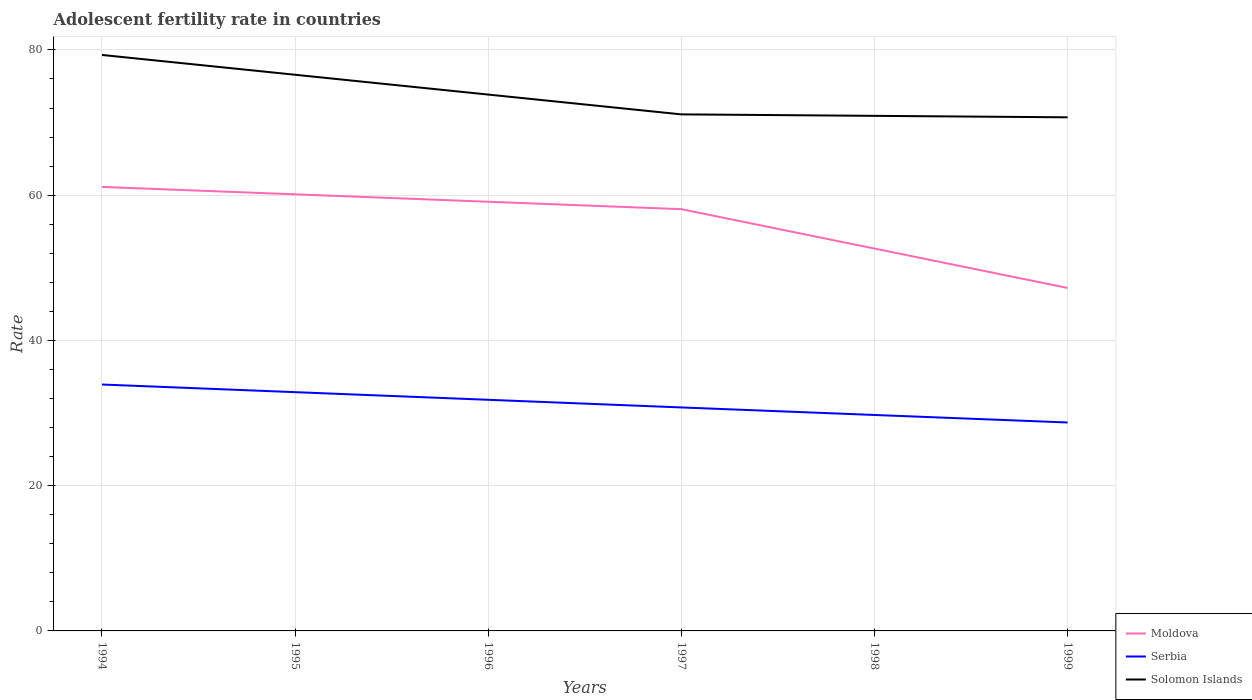Is the number of lines equal to the number of legend labels?
Your response must be concise. Yes. Across all years, what is the maximum adolescent fertility rate in Moldova?
Keep it short and to the point. 47.23. In which year was the adolescent fertility rate in Moldova maximum?
Offer a very short reply. 1999. What is the total adolescent fertility rate in Solomon Islands in the graph?
Offer a terse response. 0.4. What is the difference between the highest and the second highest adolescent fertility rate in Moldova?
Offer a terse response. 13.91. What is the difference between the highest and the lowest adolescent fertility rate in Serbia?
Your response must be concise. 3. Is the adolescent fertility rate in Moldova strictly greater than the adolescent fertility rate in Serbia over the years?
Offer a terse response. No. Are the values on the major ticks of Y-axis written in scientific E-notation?
Give a very brief answer. No. Where does the legend appear in the graph?
Your answer should be compact. Bottom right. How many legend labels are there?
Provide a succinct answer. 3. What is the title of the graph?
Offer a very short reply. Adolescent fertility rate in countries. Does "Vietnam" appear as one of the legend labels in the graph?
Provide a short and direct response. No. What is the label or title of the X-axis?
Provide a succinct answer. Years. What is the label or title of the Y-axis?
Provide a succinct answer. Rate. What is the Rate of Moldova in 1994?
Your answer should be very brief. 61.14. What is the Rate in Serbia in 1994?
Offer a terse response. 33.93. What is the Rate of Solomon Islands in 1994?
Provide a succinct answer. 79.31. What is the Rate in Moldova in 1995?
Your response must be concise. 60.11. What is the Rate of Serbia in 1995?
Offer a terse response. 32.88. What is the Rate in Solomon Islands in 1995?
Your answer should be very brief. 76.58. What is the Rate in Moldova in 1996?
Provide a short and direct response. 59.09. What is the Rate of Serbia in 1996?
Provide a short and direct response. 31.82. What is the Rate in Solomon Islands in 1996?
Keep it short and to the point. 73.85. What is the Rate of Moldova in 1997?
Offer a very short reply. 58.07. What is the Rate of Serbia in 1997?
Ensure brevity in your answer.  30.77. What is the Rate of Solomon Islands in 1997?
Ensure brevity in your answer.  71.12. What is the Rate in Moldova in 1998?
Give a very brief answer. 52.65. What is the Rate of Serbia in 1998?
Provide a succinct answer. 29.74. What is the Rate of Solomon Islands in 1998?
Your answer should be compact. 70.92. What is the Rate in Moldova in 1999?
Provide a succinct answer. 47.23. What is the Rate of Serbia in 1999?
Ensure brevity in your answer.  28.7. What is the Rate in Solomon Islands in 1999?
Offer a terse response. 70.72. Across all years, what is the maximum Rate in Moldova?
Give a very brief answer. 61.14. Across all years, what is the maximum Rate of Serbia?
Your answer should be compact. 33.93. Across all years, what is the maximum Rate in Solomon Islands?
Keep it short and to the point. 79.31. Across all years, what is the minimum Rate in Moldova?
Provide a succinct answer. 47.23. Across all years, what is the minimum Rate in Serbia?
Provide a short and direct response. 28.7. Across all years, what is the minimum Rate in Solomon Islands?
Your response must be concise. 70.72. What is the total Rate in Moldova in the graph?
Make the answer very short. 338.29. What is the total Rate in Serbia in the graph?
Your answer should be very brief. 187.83. What is the total Rate of Solomon Islands in the graph?
Your answer should be compact. 442.5. What is the difference between the Rate of Moldova in 1994 and that in 1995?
Your answer should be compact. 1.02. What is the difference between the Rate of Serbia in 1994 and that in 1995?
Your answer should be very brief. 1.05. What is the difference between the Rate of Solomon Islands in 1994 and that in 1995?
Your response must be concise. 2.73. What is the difference between the Rate of Moldova in 1994 and that in 1996?
Your answer should be very brief. 2.04. What is the difference between the Rate in Serbia in 1994 and that in 1996?
Give a very brief answer. 2.1. What is the difference between the Rate in Solomon Islands in 1994 and that in 1996?
Provide a short and direct response. 5.46. What is the difference between the Rate in Moldova in 1994 and that in 1997?
Your answer should be very brief. 3.06. What is the difference between the Rate in Serbia in 1994 and that in 1997?
Your answer should be compact. 3.16. What is the difference between the Rate in Solomon Islands in 1994 and that in 1997?
Your answer should be compact. 8.18. What is the difference between the Rate of Moldova in 1994 and that in 1998?
Provide a short and direct response. 8.49. What is the difference between the Rate in Serbia in 1994 and that in 1998?
Offer a very short reply. 4.19. What is the difference between the Rate of Solomon Islands in 1994 and that in 1998?
Give a very brief answer. 8.38. What is the difference between the Rate in Moldova in 1994 and that in 1999?
Keep it short and to the point. 13.91. What is the difference between the Rate of Serbia in 1994 and that in 1999?
Your answer should be very brief. 5.23. What is the difference between the Rate of Solomon Islands in 1994 and that in 1999?
Keep it short and to the point. 8.59. What is the difference between the Rate of Moldova in 1995 and that in 1996?
Ensure brevity in your answer.  1.02. What is the difference between the Rate in Serbia in 1995 and that in 1996?
Provide a succinct answer. 1.05. What is the difference between the Rate in Solomon Islands in 1995 and that in 1996?
Provide a succinct answer. 2.73. What is the difference between the Rate in Moldova in 1995 and that in 1997?
Your response must be concise. 2.04. What is the difference between the Rate in Serbia in 1995 and that in 1997?
Give a very brief answer. 2.1. What is the difference between the Rate of Solomon Islands in 1995 and that in 1997?
Keep it short and to the point. 5.46. What is the difference between the Rate in Moldova in 1995 and that in 1998?
Offer a terse response. 7.47. What is the difference between the Rate in Serbia in 1995 and that in 1998?
Make the answer very short. 3.14. What is the difference between the Rate in Solomon Islands in 1995 and that in 1998?
Give a very brief answer. 5.66. What is the difference between the Rate in Moldova in 1995 and that in 1999?
Provide a short and direct response. 12.89. What is the difference between the Rate of Serbia in 1995 and that in 1999?
Make the answer very short. 4.18. What is the difference between the Rate of Solomon Islands in 1995 and that in 1999?
Your response must be concise. 5.86. What is the difference between the Rate of Moldova in 1996 and that in 1997?
Ensure brevity in your answer.  1.02. What is the difference between the Rate in Serbia in 1996 and that in 1997?
Your response must be concise. 1.05. What is the difference between the Rate in Solomon Islands in 1996 and that in 1997?
Ensure brevity in your answer.  2.73. What is the difference between the Rate of Moldova in 1996 and that in 1998?
Ensure brevity in your answer.  6.44. What is the difference between the Rate in Serbia in 1996 and that in 1998?
Offer a terse response. 2.09. What is the difference between the Rate of Solomon Islands in 1996 and that in 1998?
Give a very brief answer. 2.93. What is the difference between the Rate of Moldova in 1996 and that in 1999?
Your answer should be compact. 11.87. What is the difference between the Rate in Serbia in 1996 and that in 1999?
Keep it short and to the point. 3.12. What is the difference between the Rate of Solomon Islands in 1996 and that in 1999?
Offer a terse response. 3.13. What is the difference between the Rate in Moldova in 1997 and that in 1998?
Your answer should be very brief. 5.42. What is the difference between the Rate in Serbia in 1997 and that in 1998?
Keep it short and to the point. 1.04. What is the difference between the Rate in Solomon Islands in 1997 and that in 1998?
Provide a succinct answer. 0.2. What is the difference between the Rate in Moldova in 1997 and that in 1999?
Provide a short and direct response. 10.85. What is the difference between the Rate of Serbia in 1997 and that in 1999?
Ensure brevity in your answer.  2.07. What is the difference between the Rate in Solomon Islands in 1997 and that in 1999?
Give a very brief answer. 0.4. What is the difference between the Rate in Moldova in 1998 and that in 1999?
Provide a succinct answer. 5.42. What is the difference between the Rate in Serbia in 1998 and that in 1999?
Your answer should be compact. 1.04. What is the difference between the Rate of Solomon Islands in 1998 and that in 1999?
Your answer should be very brief. 0.2. What is the difference between the Rate in Moldova in 1994 and the Rate in Serbia in 1995?
Offer a very short reply. 28.26. What is the difference between the Rate of Moldova in 1994 and the Rate of Solomon Islands in 1995?
Make the answer very short. -15.44. What is the difference between the Rate of Serbia in 1994 and the Rate of Solomon Islands in 1995?
Your answer should be very brief. -42.65. What is the difference between the Rate of Moldova in 1994 and the Rate of Serbia in 1996?
Make the answer very short. 29.31. What is the difference between the Rate of Moldova in 1994 and the Rate of Solomon Islands in 1996?
Offer a terse response. -12.71. What is the difference between the Rate of Serbia in 1994 and the Rate of Solomon Islands in 1996?
Your response must be concise. -39.92. What is the difference between the Rate of Moldova in 1994 and the Rate of Serbia in 1997?
Offer a terse response. 30.36. What is the difference between the Rate in Moldova in 1994 and the Rate in Solomon Islands in 1997?
Your answer should be very brief. -9.99. What is the difference between the Rate in Serbia in 1994 and the Rate in Solomon Islands in 1997?
Your answer should be compact. -37.19. What is the difference between the Rate of Moldova in 1994 and the Rate of Serbia in 1998?
Keep it short and to the point. 31.4. What is the difference between the Rate of Moldova in 1994 and the Rate of Solomon Islands in 1998?
Offer a terse response. -9.79. What is the difference between the Rate of Serbia in 1994 and the Rate of Solomon Islands in 1998?
Ensure brevity in your answer.  -36.99. What is the difference between the Rate in Moldova in 1994 and the Rate in Serbia in 1999?
Give a very brief answer. 32.44. What is the difference between the Rate of Moldova in 1994 and the Rate of Solomon Islands in 1999?
Offer a terse response. -9.58. What is the difference between the Rate in Serbia in 1994 and the Rate in Solomon Islands in 1999?
Ensure brevity in your answer.  -36.79. What is the difference between the Rate in Moldova in 1995 and the Rate in Serbia in 1996?
Provide a succinct answer. 28.29. What is the difference between the Rate of Moldova in 1995 and the Rate of Solomon Islands in 1996?
Your answer should be compact. -13.74. What is the difference between the Rate of Serbia in 1995 and the Rate of Solomon Islands in 1996?
Offer a terse response. -40.97. What is the difference between the Rate of Moldova in 1995 and the Rate of Serbia in 1997?
Make the answer very short. 29.34. What is the difference between the Rate of Moldova in 1995 and the Rate of Solomon Islands in 1997?
Make the answer very short. -11.01. What is the difference between the Rate in Serbia in 1995 and the Rate in Solomon Islands in 1997?
Offer a terse response. -38.25. What is the difference between the Rate of Moldova in 1995 and the Rate of Serbia in 1998?
Offer a terse response. 30.38. What is the difference between the Rate of Moldova in 1995 and the Rate of Solomon Islands in 1998?
Ensure brevity in your answer.  -10.81. What is the difference between the Rate in Serbia in 1995 and the Rate in Solomon Islands in 1998?
Keep it short and to the point. -38.05. What is the difference between the Rate of Moldova in 1995 and the Rate of Serbia in 1999?
Provide a succinct answer. 31.41. What is the difference between the Rate of Moldova in 1995 and the Rate of Solomon Islands in 1999?
Your response must be concise. -10.6. What is the difference between the Rate of Serbia in 1995 and the Rate of Solomon Islands in 1999?
Your response must be concise. -37.84. What is the difference between the Rate of Moldova in 1996 and the Rate of Serbia in 1997?
Give a very brief answer. 28.32. What is the difference between the Rate in Moldova in 1996 and the Rate in Solomon Islands in 1997?
Keep it short and to the point. -12.03. What is the difference between the Rate of Serbia in 1996 and the Rate of Solomon Islands in 1997?
Offer a very short reply. -39.3. What is the difference between the Rate in Moldova in 1996 and the Rate in Serbia in 1998?
Provide a succinct answer. 29.36. What is the difference between the Rate in Moldova in 1996 and the Rate in Solomon Islands in 1998?
Ensure brevity in your answer.  -11.83. What is the difference between the Rate of Serbia in 1996 and the Rate of Solomon Islands in 1998?
Offer a very short reply. -39.1. What is the difference between the Rate in Moldova in 1996 and the Rate in Serbia in 1999?
Your answer should be very brief. 30.39. What is the difference between the Rate in Moldova in 1996 and the Rate in Solomon Islands in 1999?
Make the answer very short. -11.63. What is the difference between the Rate in Serbia in 1996 and the Rate in Solomon Islands in 1999?
Offer a very short reply. -38.9. What is the difference between the Rate of Moldova in 1997 and the Rate of Serbia in 1998?
Keep it short and to the point. 28.34. What is the difference between the Rate of Moldova in 1997 and the Rate of Solomon Islands in 1998?
Provide a short and direct response. -12.85. What is the difference between the Rate of Serbia in 1997 and the Rate of Solomon Islands in 1998?
Make the answer very short. -40.15. What is the difference between the Rate in Moldova in 1997 and the Rate in Serbia in 1999?
Your answer should be compact. 29.37. What is the difference between the Rate in Moldova in 1997 and the Rate in Solomon Islands in 1999?
Your response must be concise. -12.65. What is the difference between the Rate in Serbia in 1997 and the Rate in Solomon Islands in 1999?
Ensure brevity in your answer.  -39.95. What is the difference between the Rate of Moldova in 1998 and the Rate of Serbia in 1999?
Offer a very short reply. 23.95. What is the difference between the Rate in Moldova in 1998 and the Rate in Solomon Islands in 1999?
Provide a short and direct response. -18.07. What is the difference between the Rate of Serbia in 1998 and the Rate of Solomon Islands in 1999?
Give a very brief answer. -40.98. What is the average Rate in Moldova per year?
Provide a succinct answer. 56.38. What is the average Rate of Serbia per year?
Offer a terse response. 31.31. What is the average Rate in Solomon Islands per year?
Offer a terse response. 73.75. In the year 1994, what is the difference between the Rate in Moldova and Rate in Serbia?
Your answer should be very brief. 27.21. In the year 1994, what is the difference between the Rate in Moldova and Rate in Solomon Islands?
Ensure brevity in your answer.  -18.17. In the year 1994, what is the difference between the Rate in Serbia and Rate in Solomon Islands?
Provide a succinct answer. -45.38. In the year 1995, what is the difference between the Rate in Moldova and Rate in Serbia?
Offer a very short reply. 27.24. In the year 1995, what is the difference between the Rate of Moldova and Rate of Solomon Islands?
Offer a terse response. -16.46. In the year 1995, what is the difference between the Rate in Serbia and Rate in Solomon Islands?
Your answer should be compact. -43.7. In the year 1996, what is the difference between the Rate in Moldova and Rate in Serbia?
Offer a very short reply. 27.27. In the year 1996, what is the difference between the Rate of Moldova and Rate of Solomon Islands?
Your answer should be very brief. -14.76. In the year 1996, what is the difference between the Rate in Serbia and Rate in Solomon Islands?
Offer a very short reply. -42.03. In the year 1997, what is the difference between the Rate of Moldova and Rate of Serbia?
Provide a succinct answer. 27.3. In the year 1997, what is the difference between the Rate in Moldova and Rate in Solomon Islands?
Your response must be concise. -13.05. In the year 1997, what is the difference between the Rate in Serbia and Rate in Solomon Islands?
Your answer should be very brief. -40.35. In the year 1998, what is the difference between the Rate in Moldova and Rate in Serbia?
Offer a terse response. 22.91. In the year 1998, what is the difference between the Rate of Moldova and Rate of Solomon Islands?
Your response must be concise. -18.27. In the year 1998, what is the difference between the Rate of Serbia and Rate of Solomon Islands?
Your response must be concise. -41.19. In the year 1999, what is the difference between the Rate in Moldova and Rate in Serbia?
Ensure brevity in your answer.  18.53. In the year 1999, what is the difference between the Rate of Moldova and Rate of Solomon Islands?
Offer a very short reply. -23.49. In the year 1999, what is the difference between the Rate of Serbia and Rate of Solomon Islands?
Provide a succinct answer. -42.02. What is the ratio of the Rate in Serbia in 1994 to that in 1995?
Provide a short and direct response. 1.03. What is the ratio of the Rate in Solomon Islands in 1994 to that in 1995?
Make the answer very short. 1.04. What is the ratio of the Rate of Moldova in 1994 to that in 1996?
Offer a terse response. 1.03. What is the ratio of the Rate of Serbia in 1994 to that in 1996?
Make the answer very short. 1.07. What is the ratio of the Rate in Solomon Islands in 1994 to that in 1996?
Offer a very short reply. 1.07. What is the ratio of the Rate in Moldova in 1994 to that in 1997?
Make the answer very short. 1.05. What is the ratio of the Rate of Serbia in 1994 to that in 1997?
Your answer should be compact. 1.1. What is the ratio of the Rate of Solomon Islands in 1994 to that in 1997?
Provide a succinct answer. 1.12. What is the ratio of the Rate in Moldova in 1994 to that in 1998?
Offer a very short reply. 1.16. What is the ratio of the Rate of Serbia in 1994 to that in 1998?
Give a very brief answer. 1.14. What is the ratio of the Rate in Solomon Islands in 1994 to that in 1998?
Keep it short and to the point. 1.12. What is the ratio of the Rate in Moldova in 1994 to that in 1999?
Provide a short and direct response. 1.29. What is the ratio of the Rate of Serbia in 1994 to that in 1999?
Give a very brief answer. 1.18. What is the ratio of the Rate in Solomon Islands in 1994 to that in 1999?
Give a very brief answer. 1.12. What is the ratio of the Rate of Moldova in 1995 to that in 1996?
Ensure brevity in your answer.  1.02. What is the ratio of the Rate of Serbia in 1995 to that in 1996?
Provide a succinct answer. 1.03. What is the ratio of the Rate in Solomon Islands in 1995 to that in 1996?
Offer a terse response. 1.04. What is the ratio of the Rate in Moldova in 1995 to that in 1997?
Your response must be concise. 1.04. What is the ratio of the Rate of Serbia in 1995 to that in 1997?
Offer a very short reply. 1.07. What is the ratio of the Rate of Solomon Islands in 1995 to that in 1997?
Provide a short and direct response. 1.08. What is the ratio of the Rate of Moldova in 1995 to that in 1998?
Offer a very short reply. 1.14. What is the ratio of the Rate of Serbia in 1995 to that in 1998?
Your answer should be very brief. 1.11. What is the ratio of the Rate of Solomon Islands in 1995 to that in 1998?
Your answer should be very brief. 1.08. What is the ratio of the Rate of Moldova in 1995 to that in 1999?
Make the answer very short. 1.27. What is the ratio of the Rate of Serbia in 1995 to that in 1999?
Your answer should be compact. 1.15. What is the ratio of the Rate of Solomon Islands in 1995 to that in 1999?
Offer a very short reply. 1.08. What is the ratio of the Rate in Moldova in 1996 to that in 1997?
Offer a very short reply. 1.02. What is the ratio of the Rate of Serbia in 1996 to that in 1997?
Ensure brevity in your answer.  1.03. What is the ratio of the Rate in Solomon Islands in 1996 to that in 1997?
Offer a very short reply. 1.04. What is the ratio of the Rate in Moldova in 1996 to that in 1998?
Give a very brief answer. 1.12. What is the ratio of the Rate in Serbia in 1996 to that in 1998?
Make the answer very short. 1.07. What is the ratio of the Rate of Solomon Islands in 1996 to that in 1998?
Your answer should be very brief. 1.04. What is the ratio of the Rate of Moldova in 1996 to that in 1999?
Provide a succinct answer. 1.25. What is the ratio of the Rate of Serbia in 1996 to that in 1999?
Your answer should be very brief. 1.11. What is the ratio of the Rate in Solomon Islands in 1996 to that in 1999?
Your answer should be very brief. 1.04. What is the ratio of the Rate in Moldova in 1997 to that in 1998?
Provide a succinct answer. 1.1. What is the ratio of the Rate in Serbia in 1997 to that in 1998?
Your answer should be compact. 1.03. What is the ratio of the Rate in Moldova in 1997 to that in 1999?
Your answer should be very brief. 1.23. What is the ratio of the Rate in Serbia in 1997 to that in 1999?
Provide a short and direct response. 1.07. What is the ratio of the Rate of Moldova in 1998 to that in 1999?
Offer a very short reply. 1.11. What is the ratio of the Rate of Serbia in 1998 to that in 1999?
Keep it short and to the point. 1.04. What is the ratio of the Rate in Solomon Islands in 1998 to that in 1999?
Your answer should be compact. 1. What is the difference between the highest and the second highest Rate in Moldova?
Ensure brevity in your answer.  1.02. What is the difference between the highest and the second highest Rate of Serbia?
Provide a succinct answer. 1.05. What is the difference between the highest and the second highest Rate of Solomon Islands?
Your answer should be compact. 2.73. What is the difference between the highest and the lowest Rate in Moldova?
Your answer should be compact. 13.91. What is the difference between the highest and the lowest Rate of Serbia?
Your answer should be compact. 5.23. What is the difference between the highest and the lowest Rate in Solomon Islands?
Give a very brief answer. 8.59. 